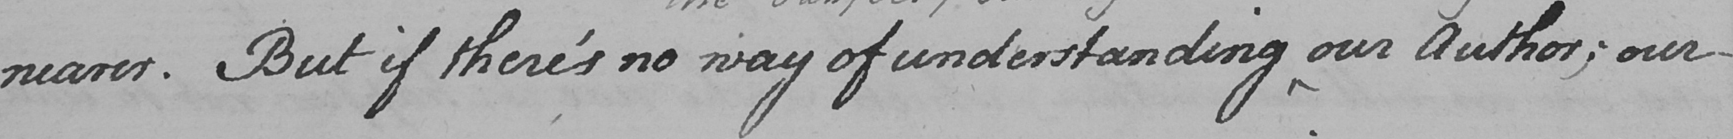Can you tell me what this handwritten text says? nearer . But if there ' s no way of understanding our Author ; our  _ 